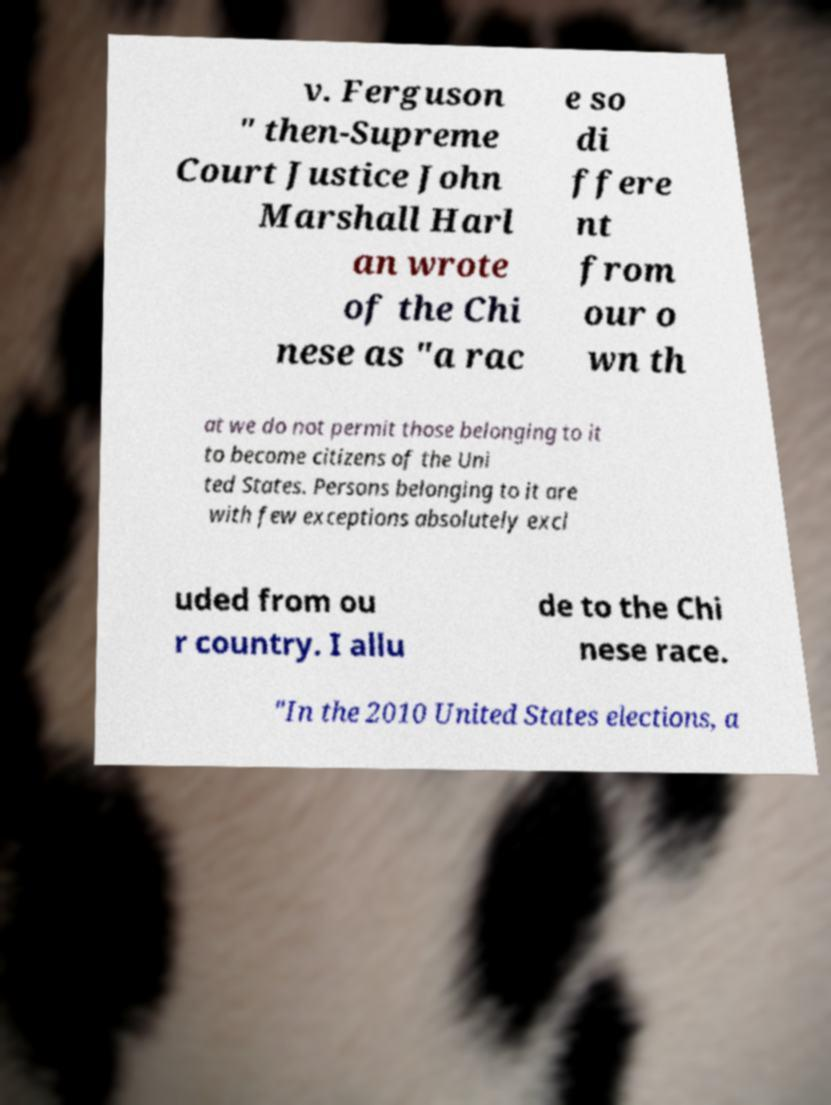There's text embedded in this image that I need extracted. Can you transcribe it verbatim? v. Ferguson " then-Supreme Court Justice John Marshall Harl an wrote of the Chi nese as "a rac e so di ffere nt from our o wn th at we do not permit those belonging to it to become citizens of the Uni ted States. Persons belonging to it are with few exceptions absolutely excl uded from ou r country. I allu de to the Chi nese race. "In the 2010 United States elections, a 